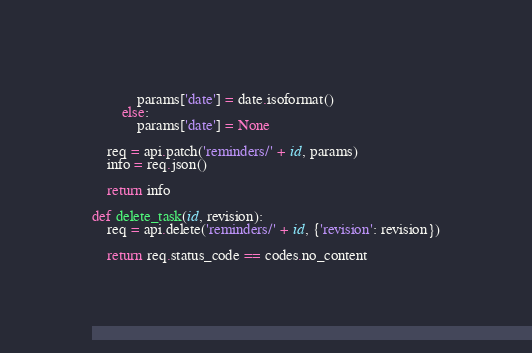<code> <loc_0><loc_0><loc_500><loc_500><_Python_>            params['date'] = date.isoformat()
        else:
            params['date'] = None

    req = api.patch('reminders/' + id, params)
    info = req.json()

    return info

def delete_task(id, revision):
    req = api.delete('reminders/' + id, {'revision': revision})

    return req.status_code == codes.no_content
</code> 